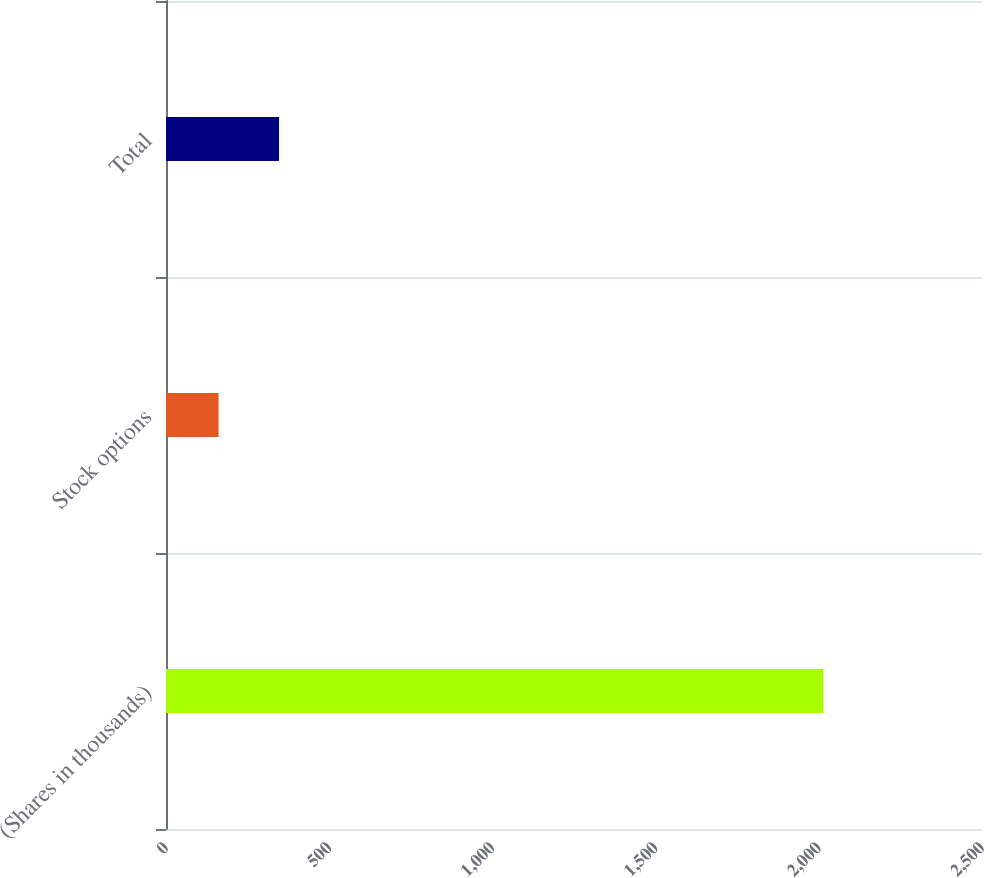Convert chart to OTSL. <chart><loc_0><loc_0><loc_500><loc_500><bar_chart><fcel>(Shares in thousands)<fcel>Stock options<fcel>Total<nl><fcel>2014<fcel>161<fcel>346.3<nl></chart> 